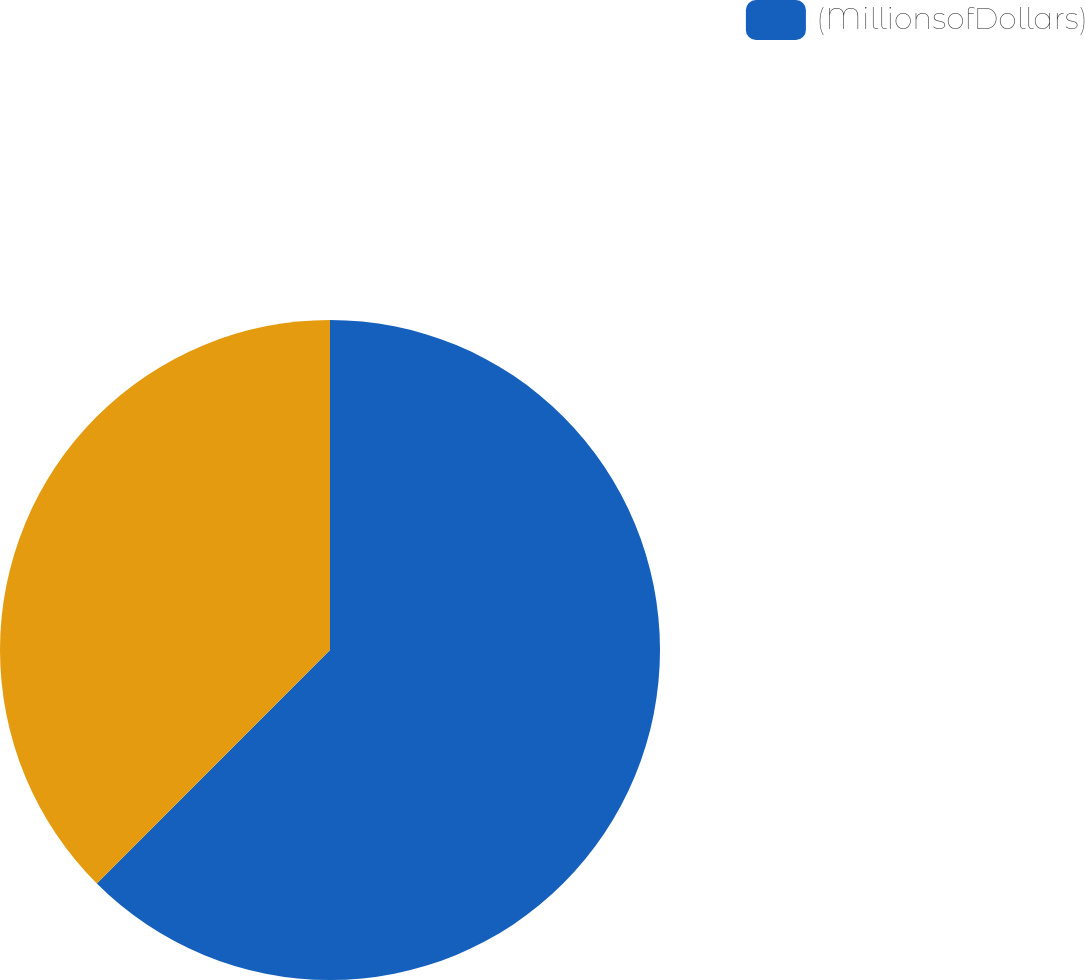Convert chart to OTSL. <chart><loc_0><loc_0><loc_500><loc_500><pie_chart><fcel>(MillionsofDollars)<fcel>Unnamed: 1<nl><fcel>62.49%<fcel>37.51%<nl></chart> 